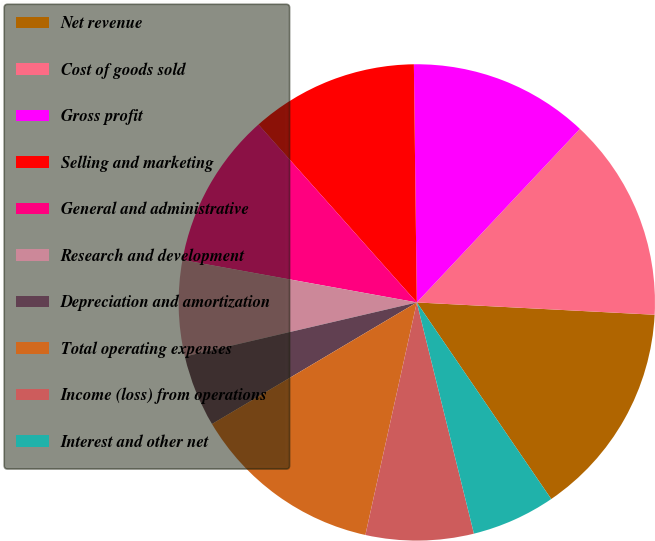Convert chart. <chart><loc_0><loc_0><loc_500><loc_500><pie_chart><fcel>Net revenue<fcel>Cost of goods sold<fcel>Gross profit<fcel>Selling and marketing<fcel>General and administrative<fcel>Research and development<fcel>Depreciation and amortization<fcel>Total operating expenses<fcel>Income (loss) from operations<fcel>Interest and other net<nl><fcel>14.63%<fcel>13.82%<fcel>12.2%<fcel>11.38%<fcel>10.57%<fcel>6.5%<fcel>4.88%<fcel>13.01%<fcel>7.32%<fcel>5.69%<nl></chart> 